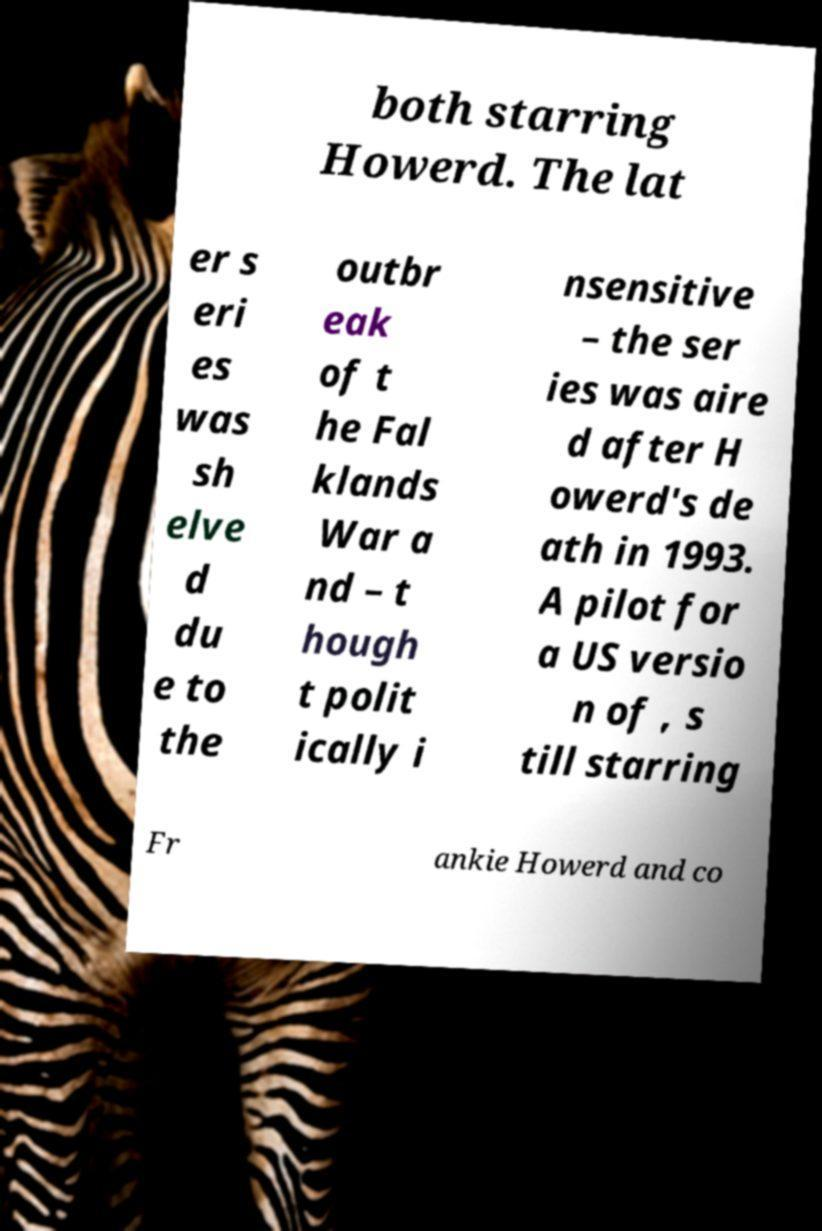For documentation purposes, I need the text within this image transcribed. Could you provide that? both starring Howerd. The lat er s eri es was sh elve d du e to the outbr eak of t he Fal klands War a nd – t hough t polit ically i nsensitive – the ser ies was aire d after H owerd's de ath in 1993. A pilot for a US versio n of , s till starring Fr ankie Howerd and co 